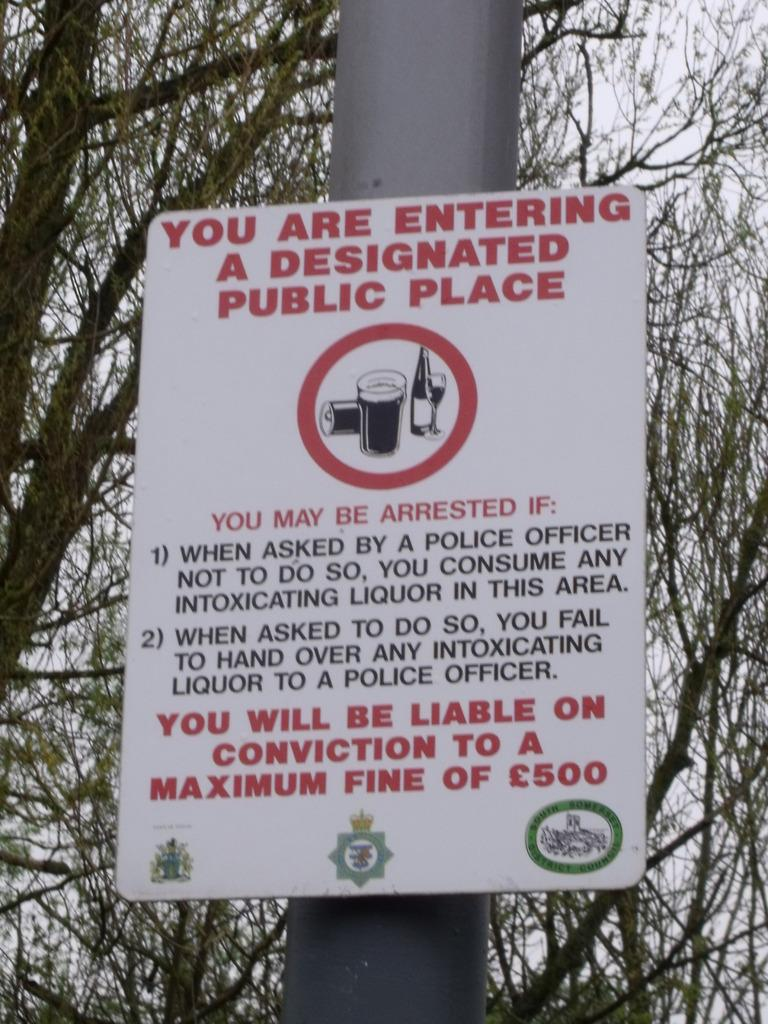What is present in the image to warn or caution people? There is a caution board in the image. What information is provided on the caution board? The caution board has text on it. How is the caution board positioned in the image? The caution board is attached to a pole. What type of natural environment is visible in the image? There are trees visible in the image. What type of nose does the governor have in the image? There is no governor present in the image, and therefore no nose to describe. Is there a bike visible in the image? There is no bike present in the image. 